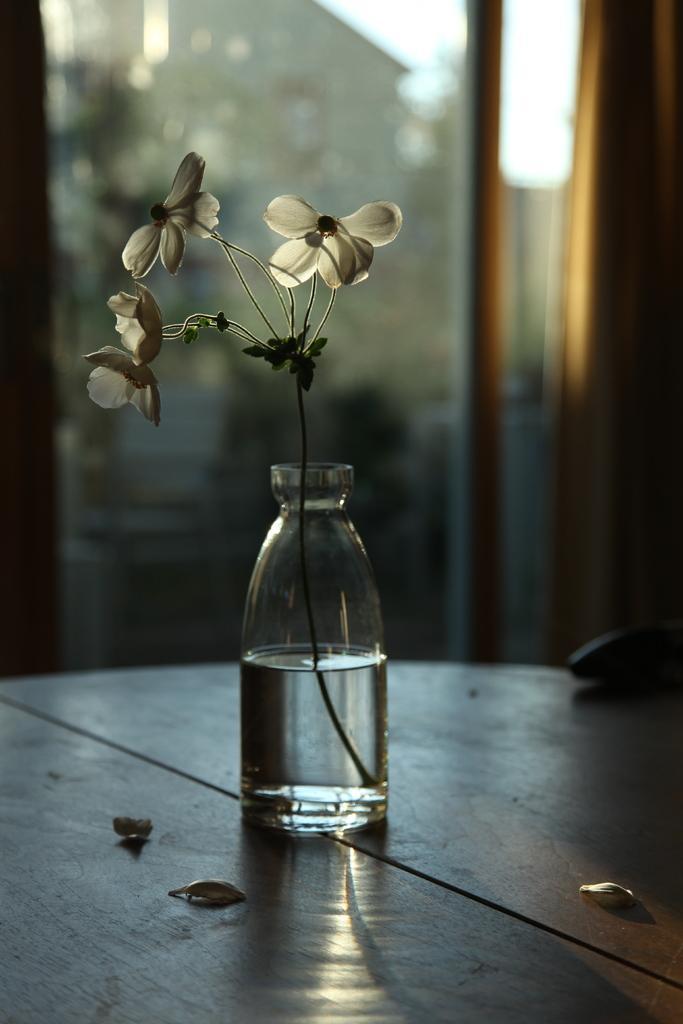Could you give a brief overview of what you see in this image? In the image we can see there is a table on which there is a glass and a water filled in it. There is a flower plant which is kept in the bottle. 